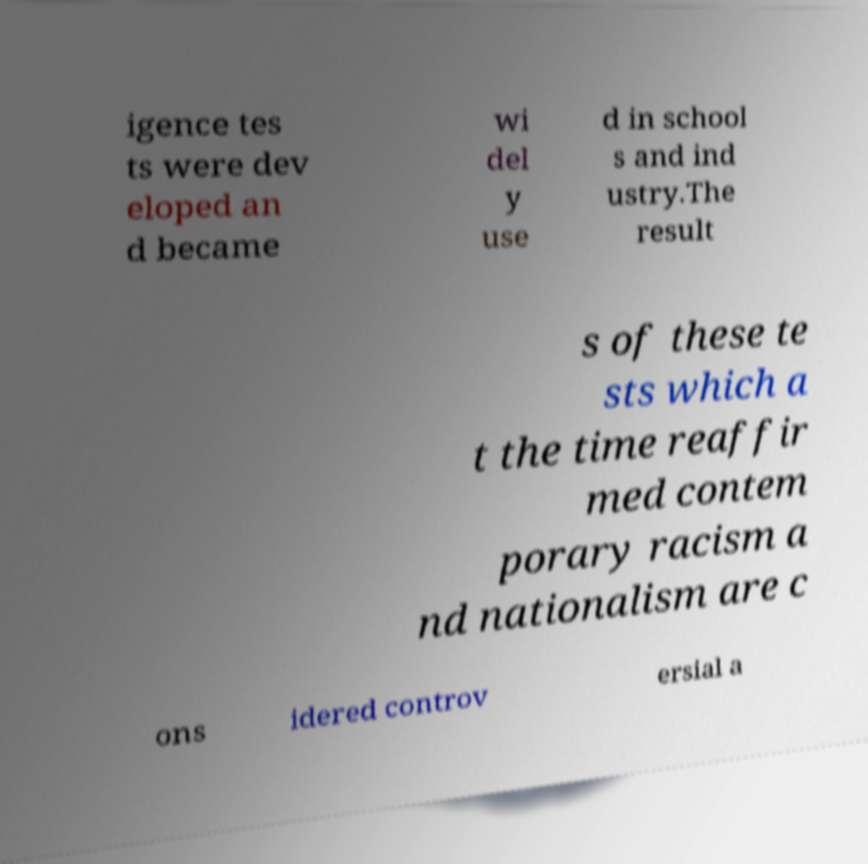Please read and relay the text visible in this image. What does it say? igence tes ts were dev eloped an d became wi del y use d in school s and ind ustry.The result s of these te sts which a t the time reaffir med contem porary racism a nd nationalism are c ons idered controv ersial a 